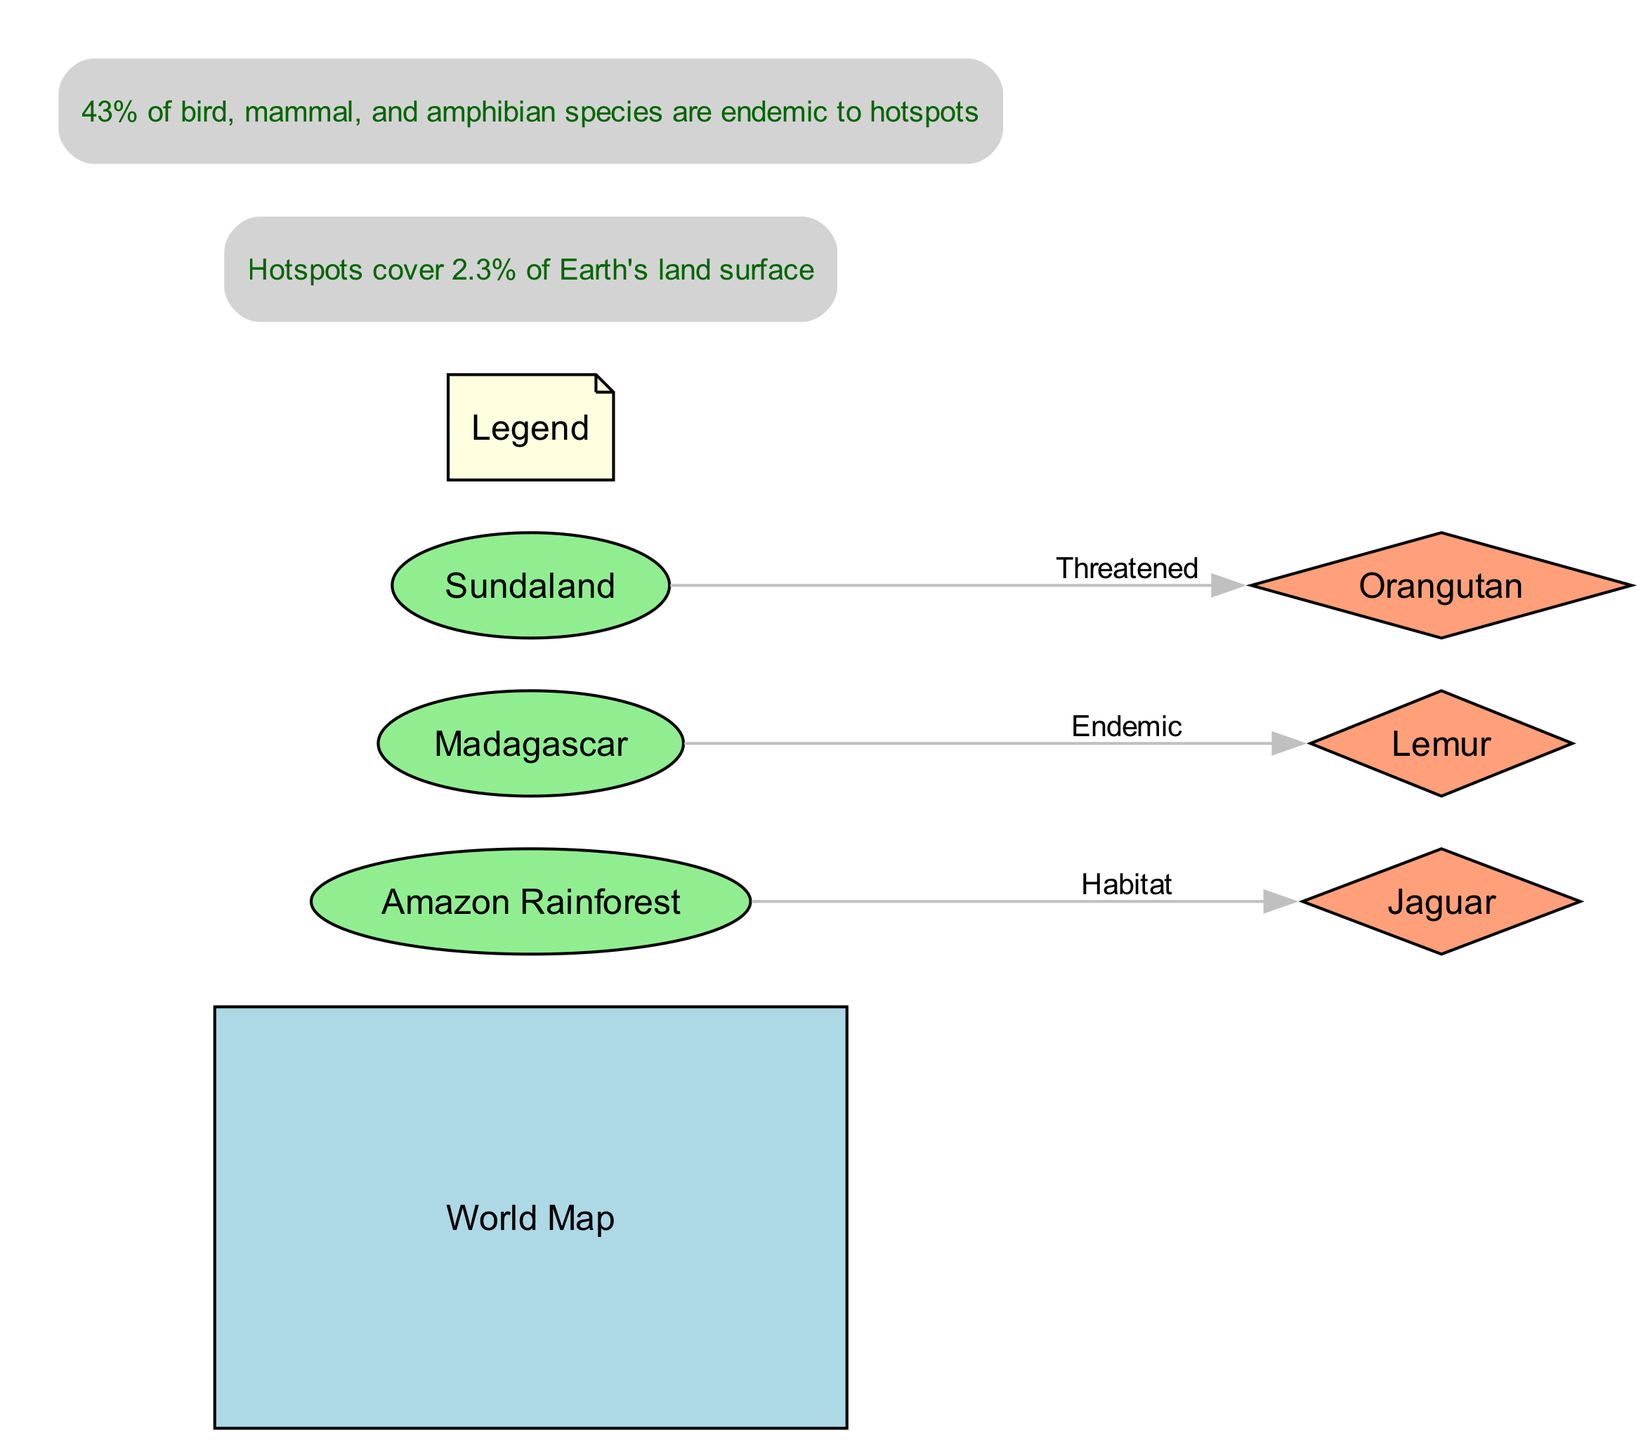What is the title of the diagram? The title is explicitly labeled at the top of the diagram and reads "Global Biodiversity Hotspots and Endangered Species Distribution."
Answer: Global Biodiversity Hotspots and Endangered Species Distribution How many biodiversity hotspots are depicted in the diagram? There are three hotspots listed in the nodes: Amazon Rainforest, Madagascar, and Sundaland. Counting these gives a total of three hotspots.
Answer: 3 Which endangered species is associated with the Amazon Rainforest? The edges connecting the hotspots to the endangered species indicate that the Jaguar is linked to the Amazon Rainforest. Therefore, the species associated with this hotspot is the Jaguar.
Answer: Jaguar How many endangered species are shown in the diagram? The diagram includes three species: Jaguar, Lemur, and Orangutan. This totals to three endangered species represented in the nodes.
Answer: 3 Which hotspot is noted for having an endemic species? According to the label on the edge originating from Madagascar, it specifies that it has an endemic species, which means it is unique to that region.
Answer: Madagascar What percentage of the Earth's land surface do biodiversity hotspots cover? The bottom annotation of the diagram explicitly states that hotspots cover 2.3% of Earth's land surface, which directly answers this question.
Answer: 2.3% What is the significance of the annotation regarding bird, mammal, and amphibian species? The annotation at the top indicates that 43% of bird, mammal, and amphibian species are endemic to hotspots, highlighting the critical role of these areas in biodiversity conservation.
Answer: 43% Which endangered species is noted as threatened in Sundaland? The edge connecting Sundaland to its respective endangered species indicates that the Orangutan is specifically labeled as threatened in this hotspot.
Answer: Orangutan How is the Lemur categorized in the diagram? The diagram categorizes the Lemur as endemic to Madagascar, as indicated by the labeling on the edge and node association.
Answer: Endemic 